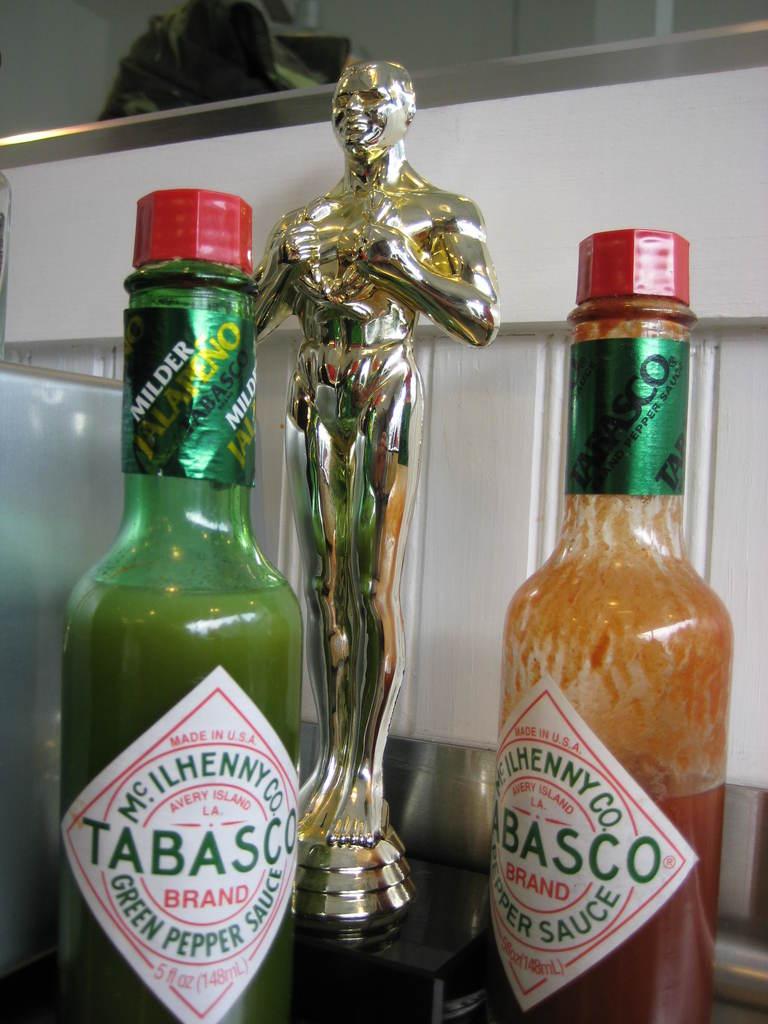What brand of hot sauce is on the counter?
Offer a very short reply. Tabasco. Who makes the hot sauce?
Your response must be concise. Tabasco. 